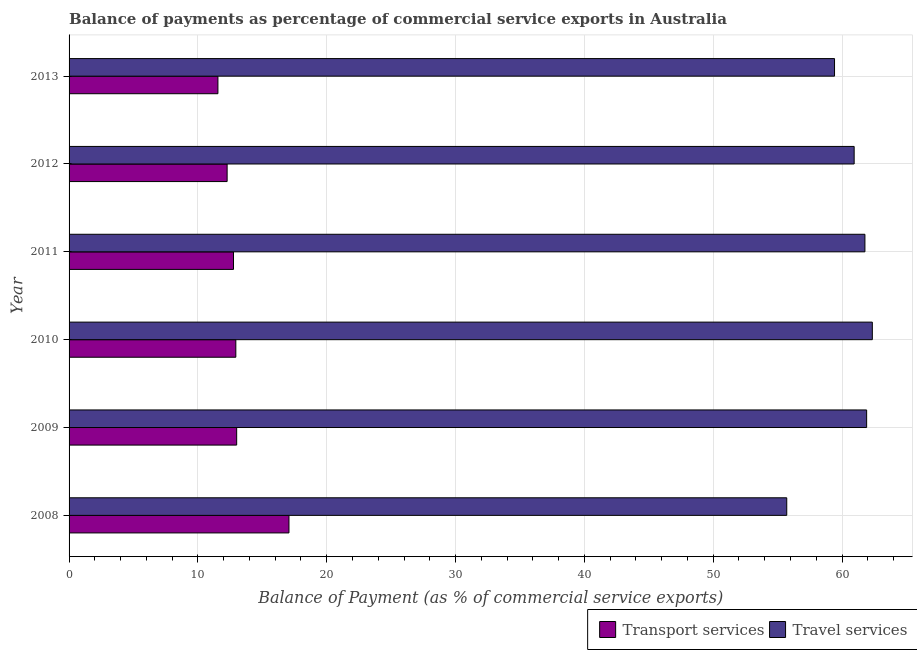How many different coloured bars are there?
Give a very brief answer. 2. Are the number of bars on each tick of the Y-axis equal?
Make the answer very short. Yes. How many bars are there on the 3rd tick from the top?
Offer a very short reply. 2. What is the balance of payments of transport services in 2013?
Your response must be concise. 11.55. Across all years, what is the maximum balance of payments of transport services?
Your response must be concise. 17.07. Across all years, what is the minimum balance of payments of travel services?
Give a very brief answer. 55.71. What is the total balance of payments of travel services in the graph?
Offer a terse response. 362.11. What is the difference between the balance of payments of travel services in 2009 and that in 2010?
Offer a very short reply. -0.44. What is the difference between the balance of payments of travel services in 2011 and the balance of payments of transport services in 2010?
Offer a terse response. 48.83. What is the average balance of payments of transport services per year?
Your answer should be very brief. 13.27. In the year 2008, what is the difference between the balance of payments of transport services and balance of payments of travel services?
Offer a terse response. -38.64. What is the ratio of the balance of payments of transport services in 2008 to that in 2009?
Offer a very short reply. 1.31. Is the difference between the balance of payments of travel services in 2009 and 2012 greater than the difference between the balance of payments of transport services in 2009 and 2012?
Provide a succinct answer. Yes. What is the difference between the highest and the second highest balance of payments of travel services?
Your response must be concise. 0.44. What is the difference between the highest and the lowest balance of payments of travel services?
Your answer should be very brief. 6.64. In how many years, is the balance of payments of travel services greater than the average balance of payments of travel services taken over all years?
Keep it short and to the point. 4. What does the 1st bar from the top in 2013 represents?
Provide a succinct answer. Travel services. What does the 1st bar from the bottom in 2008 represents?
Offer a very short reply. Transport services. How many bars are there?
Give a very brief answer. 12. Are all the bars in the graph horizontal?
Offer a terse response. Yes. What is the difference between two consecutive major ticks on the X-axis?
Provide a succinct answer. 10. How are the legend labels stacked?
Your response must be concise. Horizontal. What is the title of the graph?
Your response must be concise. Balance of payments as percentage of commercial service exports in Australia. Does "International Visitors" appear as one of the legend labels in the graph?
Give a very brief answer. No. What is the label or title of the X-axis?
Offer a very short reply. Balance of Payment (as % of commercial service exports). What is the Balance of Payment (as % of commercial service exports) in Transport services in 2008?
Ensure brevity in your answer.  17.07. What is the Balance of Payment (as % of commercial service exports) in Travel services in 2008?
Your response must be concise. 55.71. What is the Balance of Payment (as % of commercial service exports) of Transport services in 2009?
Ensure brevity in your answer.  13.01. What is the Balance of Payment (as % of commercial service exports) in Travel services in 2009?
Provide a succinct answer. 61.91. What is the Balance of Payment (as % of commercial service exports) of Transport services in 2010?
Provide a short and direct response. 12.94. What is the Balance of Payment (as % of commercial service exports) of Travel services in 2010?
Offer a terse response. 62.35. What is the Balance of Payment (as % of commercial service exports) in Transport services in 2011?
Your answer should be very brief. 12.76. What is the Balance of Payment (as % of commercial service exports) of Travel services in 2011?
Keep it short and to the point. 61.78. What is the Balance of Payment (as % of commercial service exports) in Transport services in 2012?
Your answer should be very brief. 12.27. What is the Balance of Payment (as % of commercial service exports) of Travel services in 2012?
Your answer should be very brief. 60.94. What is the Balance of Payment (as % of commercial service exports) in Transport services in 2013?
Provide a short and direct response. 11.55. What is the Balance of Payment (as % of commercial service exports) in Travel services in 2013?
Provide a succinct answer. 59.42. Across all years, what is the maximum Balance of Payment (as % of commercial service exports) of Transport services?
Ensure brevity in your answer.  17.07. Across all years, what is the maximum Balance of Payment (as % of commercial service exports) of Travel services?
Offer a very short reply. 62.35. Across all years, what is the minimum Balance of Payment (as % of commercial service exports) of Transport services?
Provide a short and direct response. 11.55. Across all years, what is the minimum Balance of Payment (as % of commercial service exports) in Travel services?
Your response must be concise. 55.71. What is the total Balance of Payment (as % of commercial service exports) in Transport services in the graph?
Provide a succinct answer. 79.61. What is the total Balance of Payment (as % of commercial service exports) in Travel services in the graph?
Give a very brief answer. 362.11. What is the difference between the Balance of Payment (as % of commercial service exports) in Transport services in 2008 and that in 2009?
Offer a terse response. 4.06. What is the difference between the Balance of Payment (as % of commercial service exports) of Travel services in 2008 and that in 2009?
Offer a terse response. -6.2. What is the difference between the Balance of Payment (as % of commercial service exports) of Transport services in 2008 and that in 2010?
Ensure brevity in your answer.  4.12. What is the difference between the Balance of Payment (as % of commercial service exports) of Travel services in 2008 and that in 2010?
Offer a very short reply. -6.64. What is the difference between the Balance of Payment (as % of commercial service exports) in Transport services in 2008 and that in 2011?
Give a very brief answer. 4.31. What is the difference between the Balance of Payment (as % of commercial service exports) in Travel services in 2008 and that in 2011?
Keep it short and to the point. -6.07. What is the difference between the Balance of Payment (as % of commercial service exports) of Transport services in 2008 and that in 2012?
Your answer should be very brief. 4.8. What is the difference between the Balance of Payment (as % of commercial service exports) in Travel services in 2008 and that in 2012?
Give a very brief answer. -5.23. What is the difference between the Balance of Payment (as % of commercial service exports) in Transport services in 2008 and that in 2013?
Your answer should be very brief. 5.52. What is the difference between the Balance of Payment (as % of commercial service exports) of Travel services in 2008 and that in 2013?
Your answer should be very brief. -3.71. What is the difference between the Balance of Payment (as % of commercial service exports) in Transport services in 2009 and that in 2010?
Your answer should be compact. 0.06. What is the difference between the Balance of Payment (as % of commercial service exports) in Travel services in 2009 and that in 2010?
Keep it short and to the point. -0.44. What is the difference between the Balance of Payment (as % of commercial service exports) in Transport services in 2009 and that in 2011?
Provide a short and direct response. 0.25. What is the difference between the Balance of Payment (as % of commercial service exports) in Travel services in 2009 and that in 2011?
Provide a short and direct response. 0.13. What is the difference between the Balance of Payment (as % of commercial service exports) of Transport services in 2009 and that in 2012?
Your response must be concise. 0.74. What is the difference between the Balance of Payment (as % of commercial service exports) in Travel services in 2009 and that in 2012?
Offer a very short reply. 0.97. What is the difference between the Balance of Payment (as % of commercial service exports) of Transport services in 2009 and that in 2013?
Ensure brevity in your answer.  1.46. What is the difference between the Balance of Payment (as % of commercial service exports) in Travel services in 2009 and that in 2013?
Provide a succinct answer. 2.49. What is the difference between the Balance of Payment (as % of commercial service exports) in Transport services in 2010 and that in 2011?
Your answer should be very brief. 0.18. What is the difference between the Balance of Payment (as % of commercial service exports) of Travel services in 2010 and that in 2011?
Make the answer very short. 0.57. What is the difference between the Balance of Payment (as % of commercial service exports) of Transport services in 2010 and that in 2012?
Your answer should be compact. 0.68. What is the difference between the Balance of Payment (as % of commercial service exports) in Travel services in 2010 and that in 2012?
Give a very brief answer. 1.41. What is the difference between the Balance of Payment (as % of commercial service exports) in Transport services in 2010 and that in 2013?
Offer a very short reply. 1.39. What is the difference between the Balance of Payment (as % of commercial service exports) of Travel services in 2010 and that in 2013?
Your answer should be compact. 2.93. What is the difference between the Balance of Payment (as % of commercial service exports) of Transport services in 2011 and that in 2012?
Ensure brevity in your answer.  0.49. What is the difference between the Balance of Payment (as % of commercial service exports) in Travel services in 2011 and that in 2012?
Offer a very short reply. 0.84. What is the difference between the Balance of Payment (as % of commercial service exports) of Transport services in 2011 and that in 2013?
Give a very brief answer. 1.21. What is the difference between the Balance of Payment (as % of commercial service exports) of Travel services in 2011 and that in 2013?
Keep it short and to the point. 2.36. What is the difference between the Balance of Payment (as % of commercial service exports) of Transport services in 2012 and that in 2013?
Keep it short and to the point. 0.71. What is the difference between the Balance of Payment (as % of commercial service exports) in Travel services in 2012 and that in 2013?
Keep it short and to the point. 1.52. What is the difference between the Balance of Payment (as % of commercial service exports) in Transport services in 2008 and the Balance of Payment (as % of commercial service exports) in Travel services in 2009?
Give a very brief answer. -44.84. What is the difference between the Balance of Payment (as % of commercial service exports) in Transport services in 2008 and the Balance of Payment (as % of commercial service exports) in Travel services in 2010?
Provide a short and direct response. -45.28. What is the difference between the Balance of Payment (as % of commercial service exports) of Transport services in 2008 and the Balance of Payment (as % of commercial service exports) of Travel services in 2011?
Make the answer very short. -44.71. What is the difference between the Balance of Payment (as % of commercial service exports) in Transport services in 2008 and the Balance of Payment (as % of commercial service exports) in Travel services in 2012?
Your answer should be very brief. -43.87. What is the difference between the Balance of Payment (as % of commercial service exports) in Transport services in 2008 and the Balance of Payment (as % of commercial service exports) in Travel services in 2013?
Offer a terse response. -42.35. What is the difference between the Balance of Payment (as % of commercial service exports) of Transport services in 2009 and the Balance of Payment (as % of commercial service exports) of Travel services in 2010?
Your answer should be very brief. -49.34. What is the difference between the Balance of Payment (as % of commercial service exports) in Transport services in 2009 and the Balance of Payment (as % of commercial service exports) in Travel services in 2011?
Offer a very short reply. -48.77. What is the difference between the Balance of Payment (as % of commercial service exports) in Transport services in 2009 and the Balance of Payment (as % of commercial service exports) in Travel services in 2012?
Give a very brief answer. -47.93. What is the difference between the Balance of Payment (as % of commercial service exports) in Transport services in 2009 and the Balance of Payment (as % of commercial service exports) in Travel services in 2013?
Offer a very short reply. -46.41. What is the difference between the Balance of Payment (as % of commercial service exports) in Transport services in 2010 and the Balance of Payment (as % of commercial service exports) in Travel services in 2011?
Ensure brevity in your answer.  -48.83. What is the difference between the Balance of Payment (as % of commercial service exports) in Transport services in 2010 and the Balance of Payment (as % of commercial service exports) in Travel services in 2012?
Make the answer very short. -48. What is the difference between the Balance of Payment (as % of commercial service exports) of Transport services in 2010 and the Balance of Payment (as % of commercial service exports) of Travel services in 2013?
Offer a terse response. -46.47. What is the difference between the Balance of Payment (as % of commercial service exports) of Transport services in 2011 and the Balance of Payment (as % of commercial service exports) of Travel services in 2012?
Provide a succinct answer. -48.18. What is the difference between the Balance of Payment (as % of commercial service exports) of Transport services in 2011 and the Balance of Payment (as % of commercial service exports) of Travel services in 2013?
Offer a very short reply. -46.65. What is the difference between the Balance of Payment (as % of commercial service exports) of Transport services in 2012 and the Balance of Payment (as % of commercial service exports) of Travel services in 2013?
Your answer should be compact. -47.15. What is the average Balance of Payment (as % of commercial service exports) of Transport services per year?
Give a very brief answer. 13.27. What is the average Balance of Payment (as % of commercial service exports) of Travel services per year?
Provide a short and direct response. 60.35. In the year 2008, what is the difference between the Balance of Payment (as % of commercial service exports) in Transport services and Balance of Payment (as % of commercial service exports) in Travel services?
Your answer should be very brief. -38.64. In the year 2009, what is the difference between the Balance of Payment (as % of commercial service exports) of Transport services and Balance of Payment (as % of commercial service exports) of Travel services?
Ensure brevity in your answer.  -48.9. In the year 2010, what is the difference between the Balance of Payment (as % of commercial service exports) in Transport services and Balance of Payment (as % of commercial service exports) in Travel services?
Ensure brevity in your answer.  -49.41. In the year 2011, what is the difference between the Balance of Payment (as % of commercial service exports) in Transport services and Balance of Payment (as % of commercial service exports) in Travel services?
Your answer should be very brief. -49.01. In the year 2012, what is the difference between the Balance of Payment (as % of commercial service exports) of Transport services and Balance of Payment (as % of commercial service exports) of Travel services?
Provide a short and direct response. -48.67. In the year 2013, what is the difference between the Balance of Payment (as % of commercial service exports) in Transport services and Balance of Payment (as % of commercial service exports) in Travel services?
Make the answer very short. -47.86. What is the ratio of the Balance of Payment (as % of commercial service exports) in Transport services in 2008 to that in 2009?
Offer a terse response. 1.31. What is the ratio of the Balance of Payment (as % of commercial service exports) of Travel services in 2008 to that in 2009?
Provide a short and direct response. 0.9. What is the ratio of the Balance of Payment (as % of commercial service exports) in Transport services in 2008 to that in 2010?
Give a very brief answer. 1.32. What is the ratio of the Balance of Payment (as % of commercial service exports) in Travel services in 2008 to that in 2010?
Keep it short and to the point. 0.89. What is the ratio of the Balance of Payment (as % of commercial service exports) of Transport services in 2008 to that in 2011?
Your response must be concise. 1.34. What is the ratio of the Balance of Payment (as % of commercial service exports) in Travel services in 2008 to that in 2011?
Your answer should be compact. 0.9. What is the ratio of the Balance of Payment (as % of commercial service exports) in Transport services in 2008 to that in 2012?
Provide a succinct answer. 1.39. What is the ratio of the Balance of Payment (as % of commercial service exports) of Travel services in 2008 to that in 2012?
Provide a short and direct response. 0.91. What is the ratio of the Balance of Payment (as % of commercial service exports) in Transport services in 2008 to that in 2013?
Keep it short and to the point. 1.48. What is the ratio of the Balance of Payment (as % of commercial service exports) in Travel services in 2008 to that in 2013?
Your answer should be very brief. 0.94. What is the ratio of the Balance of Payment (as % of commercial service exports) in Transport services in 2009 to that in 2011?
Your answer should be compact. 1.02. What is the ratio of the Balance of Payment (as % of commercial service exports) in Transport services in 2009 to that in 2012?
Provide a succinct answer. 1.06. What is the ratio of the Balance of Payment (as % of commercial service exports) in Travel services in 2009 to that in 2012?
Give a very brief answer. 1.02. What is the ratio of the Balance of Payment (as % of commercial service exports) in Transport services in 2009 to that in 2013?
Make the answer very short. 1.13. What is the ratio of the Balance of Payment (as % of commercial service exports) in Travel services in 2009 to that in 2013?
Your response must be concise. 1.04. What is the ratio of the Balance of Payment (as % of commercial service exports) of Transport services in 2010 to that in 2011?
Keep it short and to the point. 1.01. What is the ratio of the Balance of Payment (as % of commercial service exports) in Travel services in 2010 to that in 2011?
Ensure brevity in your answer.  1.01. What is the ratio of the Balance of Payment (as % of commercial service exports) in Transport services in 2010 to that in 2012?
Keep it short and to the point. 1.06. What is the ratio of the Balance of Payment (as % of commercial service exports) of Travel services in 2010 to that in 2012?
Your answer should be very brief. 1.02. What is the ratio of the Balance of Payment (as % of commercial service exports) of Transport services in 2010 to that in 2013?
Your response must be concise. 1.12. What is the ratio of the Balance of Payment (as % of commercial service exports) in Travel services in 2010 to that in 2013?
Keep it short and to the point. 1.05. What is the ratio of the Balance of Payment (as % of commercial service exports) of Transport services in 2011 to that in 2012?
Ensure brevity in your answer.  1.04. What is the ratio of the Balance of Payment (as % of commercial service exports) of Travel services in 2011 to that in 2012?
Your answer should be compact. 1.01. What is the ratio of the Balance of Payment (as % of commercial service exports) of Transport services in 2011 to that in 2013?
Your response must be concise. 1.1. What is the ratio of the Balance of Payment (as % of commercial service exports) of Travel services in 2011 to that in 2013?
Make the answer very short. 1.04. What is the ratio of the Balance of Payment (as % of commercial service exports) in Transport services in 2012 to that in 2013?
Your response must be concise. 1.06. What is the ratio of the Balance of Payment (as % of commercial service exports) of Travel services in 2012 to that in 2013?
Keep it short and to the point. 1.03. What is the difference between the highest and the second highest Balance of Payment (as % of commercial service exports) in Transport services?
Provide a succinct answer. 4.06. What is the difference between the highest and the second highest Balance of Payment (as % of commercial service exports) of Travel services?
Provide a short and direct response. 0.44. What is the difference between the highest and the lowest Balance of Payment (as % of commercial service exports) in Transport services?
Your answer should be compact. 5.52. What is the difference between the highest and the lowest Balance of Payment (as % of commercial service exports) of Travel services?
Your answer should be compact. 6.64. 